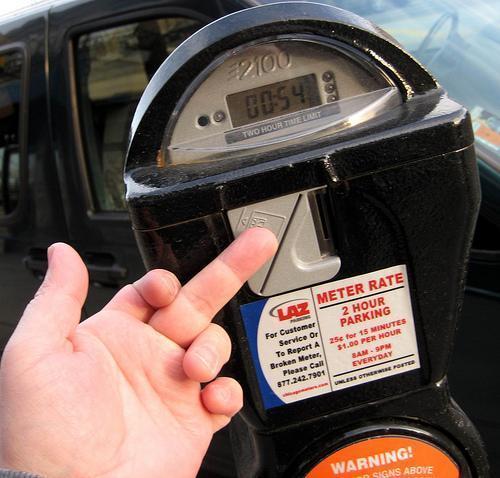How many cars are in the background?
Give a very brief answer. 1. How many fingers are up?
Give a very brief answer. 1. 